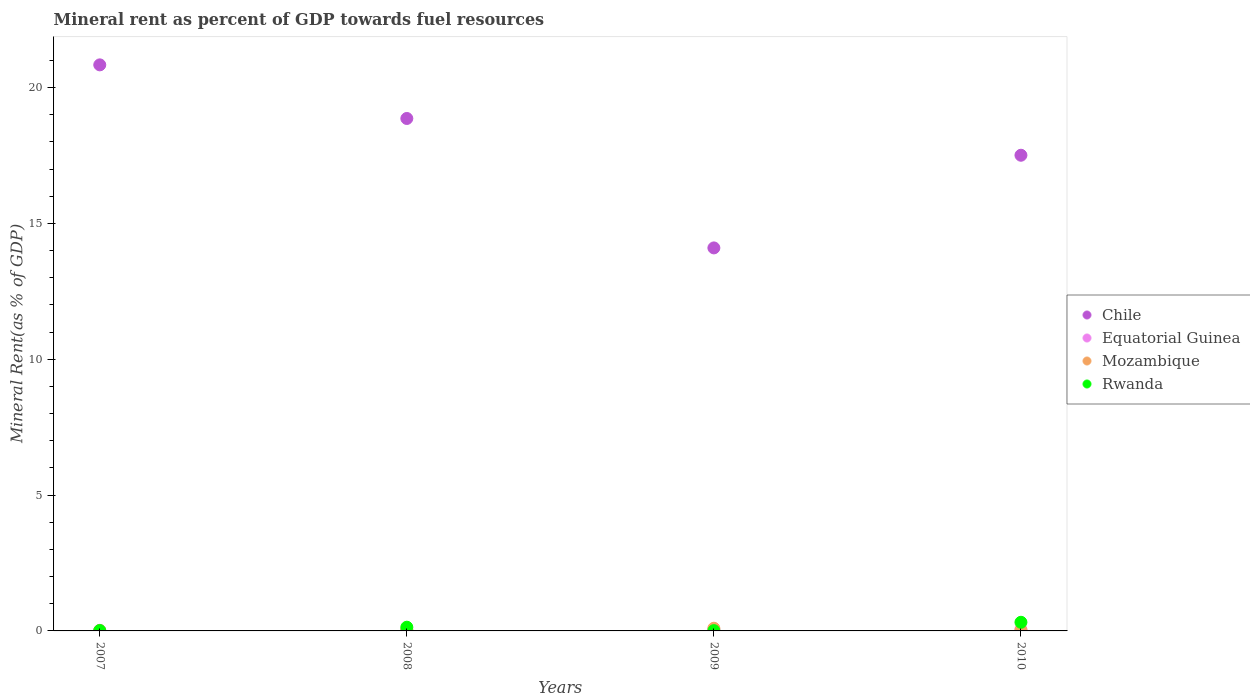How many different coloured dotlines are there?
Provide a short and direct response. 4. Is the number of dotlines equal to the number of legend labels?
Keep it short and to the point. Yes. What is the mineral rent in Rwanda in 2009?
Keep it short and to the point. 0.01. Across all years, what is the maximum mineral rent in Equatorial Guinea?
Ensure brevity in your answer.  0.05. Across all years, what is the minimum mineral rent in Mozambique?
Provide a succinct answer. 0.01. In which year was the mineral rent in Mozambique maximum?
Keep it short and to the point. 2009. What is the total mineral rent in Chile in the graph?
Your answer should be very brief. 71.3. What is the difference between the mineral rent in Equatorial Guinea in 2007 and that in 2010?
Your answer should be compact. -0.03. What is the difference between the mineral rent in Chile in 2009 and the mineral rent in Rwanda in 2007?
Ensure brevity in your answer.  14.08. What is the average mineral rent in Mozambique per year?
Keep it short and to the point. 0.05. In the year 2008, what is the difference between the mineral rent in Rwanda and mineral rent in Chile?
Your answer should be compact. -18.72. In how many years, is the mineral rent in Rwanda greater than 20 %?
Keep it short and to the point. 0. What is the ratio of the mineral rent in Rwanda in 2008 to that in 2009?
Your response must be concise. 12.42. What is the difference between the highest and the second highest mineral rent in Rwanda?
Your answer should be very brief. 0.18. What is the difference between the highest and the lowest mineral rent in Mozambique?
Your response must be concise. 0.08. In how many years, is the mineral rent in Chile greater than the average mineral rent in Chile taken over all years?
Your response must be concise. 2. Is it the case that in every year, the sum of the mineral rent in Equatorial Guinea and mineral rent in Chile  is greater than the mineral rent in Rwanda?
Offer a terse response. Yes. Does the mineral rent in Chile monotonically increase over the years?
Provide a short and direct response. No. How many dotlines are there?
Offer a very short reply. 4. Are the values on the major ticks of Y-axis written in scientific E-notation?
Offer a terse response. No. Does the graph contain grids?
Offer a very short reply. No. What is the title of the graph?
Your answer should be compact. Mineral rent as percent of GDP towards fuel resources. Does "High income: OECD" appear as one of the legend labels in the graph?
Provide a succinct answer. No. What is the label or title of the Y-axis?
Offer a terse response. Mineral Rent(as % of GDP). What is the Mineral Rent(as % of GDP) in Chile in 2007?
Your answer should be compact. 20.83. What is the Mineral Rent(as % of GDP) in Equatorial Guinea in 2007?
Ensure brevity in your answer.  0.02. What is the Mineral Rent(as % of GDP) of Mozambique in 2007?
Provide a short and direct response. 0.01. What is the Mineral Rent(as % of GDP) of Rwanda in 2007?
Offer a very short reply. 0.01. What is the Mineral Rent(as % of GDP) of Chile in 2008?
Make the answer very short. 18.86. What is the Mineral Rent(as % of GDP) in Equatorial Guinea in 2008?
Your response must be concise. 0.02. What is the Mineral Rent(as % of GDP) of Mozambique in 2008?
Provide a short and direct response. 0.05. What is the Mineral Rent(as % of GDP) of Rwanda in 2008?
Make the answer very short. 0.14. What is the Mineral Rent(as % of GDP) in Chile in 2009?
Provide a short and direct response. 14.1. What is the Mineral Rent(as % of GDP) of Equatorial Guinea in 2009?
Give a very brief answer. 0.04. What is the Mineral Rent(as % of GDP) in Mozambique in 2009?
Make the answer very short. 0.1. What is the Mineral Rent(as % of GDP) of Rwanda in 2009?
Ensure brevity in your answer.  0.01. What is the Mineral Rent(as % of GDP) in Chile in 2010?
Keep it short and to the point. 17.51. What is the Mineral Rent(as % of GDP) in Equatorial Guinea in 2010?
Offer a very short reply. 0.05. What is the Mineral Rent(as % of GDP) in Mozambique in 2010?
Provide a short and direct response. 0.03. What is the Mineral Rent(as % of GDP) of Rwanda in 2010?
Provide a short and direct response. 0.32. Across all years, what is the maximum Mineral Rent(as % of GDP) of Chile?
Make the answer very short. 20.83. Across all years, what is the maximum Mineral Rent(as % of GDP) of Equatorial Guinea?
Your response must be concise. 0.05. Across all years, what is the maximum Mineral Rent(as % of GDP) in Mozambique?
Make the answer very short. 0.1. Across all years, what is the maximum Mineral Rent(as % of GDP) of Rwanda?
Your answer should be very brief. 0.32. Across all years, what is the minimum Mineral Rent(as % of GDP) of Chile?
Offer a very short reply. 14.1. Across all years, what is the minimum Mineral Rent(as % of GDP) of Equatorial Guinea?
Your answer should be compact. 0.02. Across all years, what is the minimum Mineral Rent(as % of GDP) of Mozambique?
Your answer should be very brief. 0.01. Across all years, what is the minimum Mineral Rent(as % of GDP) in Rwanda?
Your response must be concise. 0.01. What is the total Mineral Rent(as % of GDP) of Chile in the graph?
Your response must be concise. 71.3. What is the total Mineral Rent(as % of GDP) in Equatorial Guinea in the graph?
Offer a very short reply. 0.14. What is the total Mineral Rent(as % of GDP) of Mozambique in the graph?
Offer a very short reply. 0.19. What is the total Mineral Rent(as % of GDP) of Rwanda in the graph?
Ensure brevity in your answer.  0.48. What is the difference between the Mineral Rent(as % of GDP) of Chile in 2007 and that in 2008?
Offer a terse response. 1.97. What is the difference between the Mineral Rent(as % of GDP) in Equatorial Guinea in 2007 and that in 2008?
Your answer should be compact. 0. What is the difference between the Mineral Rent(as % of GDP) of Mozambique in 2007 and that in 2008?
Your answer should be very brief. -0.03. What is the difference between the Mineral Rent(as % of GDP) in Rwanda in 2007 and that in 2008?
Give a very brief answer. -0.12. What is the difference between the Mineral Rent(as % of GDP) in Chile in 2007 and that in 2009?
Make the answer very short. 6.74. What is the difference between the Mineral Rent(as % of GDP) of Equatorial Guinea in 2007 and that in 2009?
Keep it short and to the point. -0.02. What is the difference between the Mineral Rent(as % of GDP) in Mozambique in 2007 and that in 2009?
Your response must be concise. -0.08. What is the difference between the Mineral Rent(as % of GDP) of Rwanda in 2007 and that in 2009?
Provide a short and direct response. 0. What is the difference between the Mineral Rent(as % of GDP) in Chile in 2007 and that in 2010?
Keep it short and to the point. 3.33. What is the difference between the Mineral Rent(as % of GDP) of Equatorial Guinea in 2007 and that in 2010?
Provide a short and direct response. -0.03. What is the difference between the Mineral Rent(as % of GDP) of Mozambique in 2007 and that in 2010?
Your answer should be very brief. -0.02. What is the difference between the Mineral Rent(as % of GDP) in Rwanda in 2007 and that in 2010?
Ensure brevity in your answer.  -0.3. What is the difference between the Mineral Rent(as % of GDP) of Chile in 2008 and that in 2009?
Provide a succinct answer. 4.76. What is the difference between the Mineral Rent(as % of GDP) of Equatorial Guinea in 2008 and that in 2009?
Your response must be concise. -0.02. What is the difference between the Mineral Rent(as % of GDP) of Mozambique in 2008 and that in 2009?
Give a very brief answer. -0.05. What is the difference between the Mineral Rent(as % of GDP) of Rwanda in 2008 and that in 2009?
Keep it short and to the point. 0.13. What is the difference between the Mineral Rent(as % of GDP) of Chile in 2008 and that in 2010?
Make the answer very short. 1.35. What is the difference between the Mineral Rent(as % of GDP) of Equatorial Guinea in 2008 and that in 2010?
Give a very brief answer. -0.03. What is the difference between the Mineral Rent(as % of GDP) of Mozambique in 2008 and that in 2010?
Your answer should be very brief. 0.01. What is the difference between the Mineral Rent(as % of GDP) in Rwanda in 2008 and that in 2010?
Make the answer very short. -0.18. What is the difference between the Mineral Rent(as % of GDP) in Chile in 2009 and that in 2010?
Provide a succinct answer. -3.41. What is the difference between the Mineral Rent(as % of GDP) of Equatorial Guinea in 2009 and that in 2010?
Your answer should be very brief. -0. What is the difference between the Mineral Rent(as % of GDP) of Mozambique in 2009 and that in 2010?
Your response must be concise. 0.07. What is the difference between the Mineral Rent(as % of GDP) of Rwanda in 2009 and that in 2010?
Your answer should be compact. -0.31. What is the difference between the Mineral Rent(as % of GDP) of Chile in 2007 and the Mineral Rent(as % of GDP) of Equatorial Guinea in 2008?
Keep it short and to the point. 20.81. What is the difference between the Mineral Rent(as % of GDP) in Chile in 2007 and the Mineral Rent(as % of GDP) in Mozambique in 2008?
Offer a very short reply. 20.79. What is the difference between the Mineral Rent(as % of GDP) in Chile in 2007 and the Mineral Rent(as % of GDP) in Rwanda in 2008?
Provide a short and direct response. 20.7. What is the difference between the Mineral Rent(as % of GDP) of Equatorial Guinea in 2007 and the Mineral Rent(as % of GDP) of Mozambique in 2008?
Make the answer very short. -0.02. What is the difference between the Mineral Rent(as % of GDP) in Equatorial Guinea in 2007 and the Mineral Rent(as % of GDP) in Rwanda in 2008?
Make the answer very short. -0.11. What is the difference between the Mineral Rent(as % of GDP) in Mozambique in 2007 and the Mineral Rent(as % of GDP) in Rwanda in 2008?
Your answer should be compact. -0.12. What is the difference between the Mineral Rent(as % of GDP) in Chile in 2007 and the Mineral Rent(as % of GDP) in Equatorial Guinea in 2009?
Offer a very short reply. 20.79. What is the difference between the Mineral Rent(as % of GDP) in Chile in 2007 and the Mineral Rent(as % of GDP) in Mozambique in 2009?
Your answer should be very brief. 20.73. What is the difference between the Mineral Rent(as % of GDP) in Chile in 2007 and the Mineral Rent(as % of GDP) in Rwanda in 2009?
Make the answer very short. 20.82. What is the difference between the Mineral Rent(as % of GDP) of Equatorial Guinea in 2007 and the Mineral Rent(as % of GDP) of Mozambique in 2009?
Ensure brevity in your answer.  -0.08. What is the difference between the Mineral Rent(as % of GDP) in Equatorial Guinea in 2007 and the Mineral Rent(as % of GDP) in Rwanda in 2009?
Your answer should be compact. 0.01. What is the difference between the Mineral Rent(as % of GDP) of Mozambique in 2007 and the Mineral Rent(as % of GDP) of Rwanda in 2009?
Keep it short and to the point. 0. What is the difference between the Mineral Rent(as % of GDP) in Chile in 2007 and the Mineral Rent(as % of GDP) in Equatorial Guinea in 2010?
Make the answer very short. 20.78. What is the difference between the Mineral Rent(as % of GDP) in Chile in 2007 and the Mineral Rent(as % of GDP) in Mozambique in 2010?
Provide a short and direct response. 20.8. What is the difference between the Mineral Rent(as % of GDP) of Chile in 2007 and the Mineral Rent(as % of GDP) of Rwanda in 2010?
Provide a short and direct response. 20.52. What is the difference between the Mineral Rent(as % of GDP) in Equatorial Guinea in 2007 and the Mineral Rent(as % of GDP) in Mozambique in 2010?
Provide a short and direct response. -0.01. What is the difference between the Mineral Rent(as % of GDP) of Equatorial Guinea in 2007 and the Mineral Rent(as % of GDP) of Rwanda in 2010?
Provide a succinct answer. -0.29. What is the difference between the Mineral Rent(as % of GDP) in Mozambique in 2007 and the Mineral Rent(as % of GDP) in Rwanda in 2010?
Provide a succinct answer. -0.3. What is the difference between the Mineral Rent(as % of GDP) in Chile in 2008 and the Mineral Rent(as % of GDP) in Equatorial Guinea in 2009?
Provide a short and direct response. 18.82. What is the difference between the Mineral Rent(as % of GDP) in Chile in 2008 and the Mineral Rent(as % of GDP) in Mozambique in 2009?
Ensure brevity in your answer.  18.76. What is the difference between the Mineral Rent(as % of GDP) of Chile in 2008 and the Mineral Rent(as % of GDP) of Rwanda in 2009?
Offer a very short reply. 18.85. What is the difference between the Mineral Rent(as % of GDP) in Equatorial Guinea in 2008 and the Mineral Rent(as % of GDP) in Mozambique in 2009?
Offer a very short reply. -0.08. What is the difference between the Mineral Rent(as % of GDP) of Equatorial Guinea in 2008 and the Mineral Rent(as % of GDP) of Rwanda in 2009?
Your response must be concise. 0.01. What is the difference between the Mineral Rent(as % of GDP) in Mozambique in 2008 and the Mineral Rent(as % of GDP) in Rwanda in 2009?
Keep it short and to the point. 0.03. What is the difference between the Mineral Rent(as % of GDP) of Chile in 2008 and the Mineral Rent(as % of GDP) of Equatorial Guinea in 2010?
Offer a very short reply. 18.81. What is the difference between the Mineral Rent(as % of GDP) in Chile in 2008 and the Mineral Rent(as % of GDP) in Mozambique in 2010?
Provide a succinct answer. 18.83. What is the difference between the Mineral Rent(as % of GDP) of Chile in 2008 and the Mineral Rent(as % of GDP) of Rwanda in 2010?
Provide a short and direct response. 18.54. What is the difference between the Mineral Rent(as % of GDP) of Equatorial Guinea in 2008 and the Mineral Rent(as % of GDP) of Mozambique in 2010?
Your response must be concise. -0.01. What is the difference between the Mineral Rent(as % of GDP) in Equatorial Guinea in 2008 and the Mineral Rent(as % of GDP) in Rwanda in 2010?
Provide a short and direct response. -0.3. What is the difference between the Mineral Rent(as % of GDP) of Mozambique in 2008 and the Mineral Rent(as % of GDP) of Rwanda in 2010?
Your answer should be very brief. -0.27. What is the difference between the Mineral Rent(as % of GDP) in Chile in 2009 and the Mineral Rent(as % of GDP) in Equatorial Guinea in 2010?
Provide a succinct answer. 14.05. What is the difference between the Mineral Rent(as % of GDP) of Chile in 2009 and the Mineral Rent(as % of GDP) of Mozambique in 2010?
Provide a short and direct response. 14.07. What is the difference between the Mineral Rent(as % of GDP) of Chile in 2009 and the Mineral Rent(as % of GDP) of Rwanda in 2010?
Offer a very short reply. 13.78. What is the difference between the Mineral Rent(as % of GDP) of Equatorial Guinea in 2009 and the Mineral Rent(as % of GDP) of Mozambique in 2010?
Provide a short and direct response. 0.01. What is the difference between the Mineral Rent(as % of GDP) of Equatorial Guinea in 2009 and the Mineral Rent(as % of GDP) of Rwanda in 2010?
Offer a terse response. -0.27. What is the difference between the Mineral Rent(as % of GDP) in Mozambique in 2009 and the Mineral Rent(as % of GDP) in Rwanda in 2010?
Your answer should be very brief. -0.22. What is the average Mineral Rent(as % of GDP) in Chile per year?
Give a very brief answer. 17.82. What is the average Mineral Rent(as % of GDP) in Equatorial Guinea per year?
Your answer should be very brief. 0.03. What is the average Mineral Rent(as % of GDP) of Mozambique per year?
Make the answer very short. 0.05. What is the average Mineral Rent(as % of GDP) of Rwanda per year?
Your response must be concise. 0.12. In the year 2007, what is the difference between the Mineral Rent(as % of GDP) in Chile and Mineral Rent(as % of GDP) in Equatorial Guinea?
Make the answer very short. 20.81. In the year 2007, what is the difference between the Mineral Rent(as % of GDP) in Chile and Mineral Rent(as % of GDP) in Mozambique?
Make the answer very short. 20.82. In the year 2007, what is the difference between the Mineral Rent(as % of GDP) of Chile and Mineral Rent(as % of GDP) of Rwanda?
Offer a terse response. 20.82. In the year 2007, what is the difference between the Mineral Rent(as % of GDP) in Equatorial Guinea and Mineral Rent(as % of GDP) in Mozambique?
Ensure brevity in your answer.  0.01. In the year 2007, what is the difference between the Mineral Rent(as % of GDP) in Equatorial Guinea and Mineral Rent(as % of GDP) in Rwanda?
Your answer should be very brief. 0.01. In the year 2008, what is the difference between the Mineral Rent(as % of GDP) in Chile and Mineral Rent(as % of GDP) in Equatorial Guinea?
Keep it short and to the point. 18.84. In the year 2008, what is the difference between the Mineral Rent(as % of GDP) of Chile and Mineral Rent(as % of GDP) of Mozambique?
Your response must be concise. 18.81. In the year 2008, what is the difference between the Mineral Rent(as % of GDP) of Chile and Mineral Rent(as % of GDP) of Rwanda?
Your answer should be compact. 18.72. In the year 2008, what is the difference between the Mineral Rent(as % of GDP) of Equatorial Guinea and Mineral Rent(as % of GDP) of Mozambique?
Provide a succinct answer. -0.02. In the year 2008, what is the difference between the Mineral Rent(as % of GDP) of Equatorial Guinea and Mineral Rent(as % of GDP) of Rwanda?
Your answer should be compact. -0.12. In the year 2008, what is the difference between the Mineral Rent(as % of GDP) of Mozambique and Mineral Rent(as % of GDP) of Rwanda?
Offer a terse response. -0.09. In the year 2009, what is the difference between the Mineral Rent(as % of GDP) in Chile and Mineral Rent(as % of GDP) in Equatorial Guinea?
Provide a short and direct response. 14.05. In the year 2009, what is the difference between the Mineral Rent(as % of GDP) in Chile and Mineral Rent(as % of GDP) in Mozambique?
Keep it short and to the point. 14. In the year 2009, what is the difference between the Mineral Rent(as % of GDP) of Chile and Mineral Rent(as % of GDP) of Rwanda?
Ensure brevity in your answer.  14.09. In the year 2009, what is the difference between the Mineral Rent(as % of GDP) in Equatorial Guinea and Mineral Rent(as % of GDP) in Mozambique?
Your response must be concise. -0.05. In the year 2009, what is the difference between the Mineral Rent(as % of GDP) in Equatorial Guinea and Mineral Rent(as % of GDP) in Rwanda?
Ensure brevity in your answer.  0.03. In the year 2009, what is the difference between the Mineral Rent(as % of GDP) in Mozambique and Mineral Rent(as % of GDP) in Rwanda?
Offer a very short reply. 0.09. In the year 2010, what is the difference between the Mineral Rent(as % of GDP) of Chile and Mineral Rent(as % of GDP) of Equatorial Guinea?
Your answer should be very brief. 17.46. In the year 2010, what is the difference between the Mineral Rent(as % of GDP) of Chile and Mineral Rent(as % of GDP) of Mozambique?
Your response must be concise. 17.48. In the year 2010, what is the difference between the Mineral Rent(as % of GDP) of Chile and Mineral Rent(as % of GDP) of Rwanda?
Give a very brief answer. 17.19. In the year 2010, what is the difference between the Mineral Rent(as % of GDP) of Equatorial Guinea and Mineral Rent(as % of GDP) of Mozambique?
Provide a succinct answer. 0.02. In the year 2010, what is the difference between the Mineral Rent(as % of GDP) of Equatorial Guinea and Mineral Rent(as % of GDP) of Rwanda?
Provide a short and direct response. -0.27. In the year 2010, what is the difference between the Mineral Rent(as % of GDP) of Mozambique and Mineral Rent(as % of GDP) of Rwanda?
Your answer should be compact. -0.29. What is the ratio of the Mineral Rent(as % of GDP) of Chile in 2007 to that in 2008?
Offer a terse response. 1.1. What is the ratio of the Mineral Rent(as % of GDP) in Equatorial Guinea in 2007 to that in 2008?
Keep it short and to the point. 1.08. What is the ratio of the Mineral Rent(as % of GDP) of Mozambique in 2007 to that in 2008?
Offer a terse response. 0.31. What is the ratio of the Mineral Rent(as % of GDP) of Rwanda in 2007 to that in 2008?
Provide a short and direct response. 0.1. What is the ratio of the Mineral Rent(as % of GDP) in Chile in 2007 to that in 2009?
Keep it short and to the point. 1.48. What is the ratio of the Mineral Rent(as % of GDP) in Equatorial Guinea in 2007 to that in 2009?
Your response must be concise. 0.53. What is the ratio of the Mineral Rent(as % of GDP) of Mozambique in 2007 to that in 2009?
Offer a very short reply. 0.14. What is the ratio of the Mineral Rent(as % of GDP) of Rwanda in 2007 to that in 2009?
Your answer should be very brief. 1.26. What is the ratio of the Mineral Rent(as % of GDP) of Chile in 2007 to that in 2010?
Ensure brevity in your answer.  1.19. What is the ratio of the Mineral Rent(as % of GDP) in Equatorial Guinea in 2007 to that in 2010?
Offer a terse response. 0.47. What is the ratio of the Mineral Rent(as % of GDP) of Mozambique in 2007 to that in 2010?
Your answer should be compact. 0.46. What is the ratio of the Mineral Rent(as % of GDP) of Rwanda in 2007 to that in 2010?
Provide a succinct answer. 0.04. What is the ratio of the Mineral Rent(as % of GDP) in Chile in 2008 to that in 2009?
Your answer should be very brief. 1.34. What is the ratio of the Mineral Rent(as % of GDP) in Equatorial Guinea in 2008 to that in 2009?
Offer a terse response. 0.49. What is the ratio of the Mineral Rent(as % of GDP) in Mozambique in 2008 to that in 2009?
Make the answer very short. 0.46. What is the ratio of the Mineral Rent(as % of GDP) of Rwanda in 2008 to that in 2009?
Your answer should be compact. 12.42. What is the ratio of the Mineral Rent(as % of GDP) in Chile in 2008 to that in 2010?
Your answer should be very brief. 1.08. What is the ratio of the Mineral Rent(as % of GDP) in Equatorial Guinea in 2008 to that in 2010?
Keep it short and to the point. 0.44. What is the ratio of the Mineral Rent(as % of GDP) of Mozambique in 2008 to that in 2010?
Provide a short and direct response. 1.48. What is the ratio of the Mineral Rent(as % of GDP) in Rwanda in 2008 to that in 2010?
Your answer should be very brief. 0.43. What is the ratio of the Mineral Rent(as % of GDP) in Chile in 2009 to that in 2010?
Ensure brevity in your answer.  0.81. What is the ratio of the Mineral Rent(as % of GDP) in Equatorial Guinea in 2009 to that in 2010?
Keep it short and to the point. 0.9. What is the ratio of the Mineral Rent(as % of GDP) in Mozambique in 2009 to that in 2010?
Make the answer very short. 3.23. What is the ratio of the Mineral Rent(as % of GDP) of Rwanda in 2009 to that in 2010?
Give a very brief answer. 0.03. What is the difference between the highest and the second highest Mineral Rent(as % of GDP) of Chile?
Your answer should be compact. 1.97. What is the difference between the highest and the second highest Mineral Rent(as % of GDP) in Equatorial Guinea?
Ensure brevity in your answer.  0. What is the difference between the highest and the second highest Mineral Rent(as % of GDP) in Mozambique?
Your answer should be compact. 0.05. What is the difference between the highest and the second highest Mineral Rent(as % of GDP) in Rwanda?
Offer a very short reply. 0.18. What is the difference between the highest and the lowest Mineral Rent(as % of GDP) in Chile?
Provide a short and direct response. 6.74. What is the difference between the highest and the lowest Mineral Rent(as % of GDP) of Equatorial Guinea?
Ensure brevity in your answer.  0.03. What is the difference between the highest and the lowest Mineral Rent(as % of GDP) in Mozambique?
Provide a short and direct response. 0.08. What is the difference between the highest and the lowest Mineral Rent(as % of GDP) of Rwanda?
Provide a short and direct response. 0.31. 